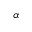<formula> <loc_0><loc_0><loc_500><loc_500>\alpha</formula> 